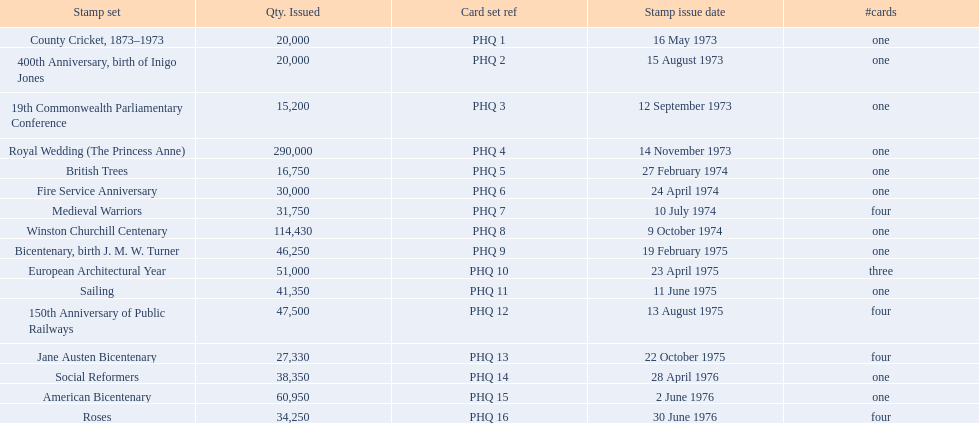What are all the stamp sets? County Cricket, 1873–1973, 400th Anniversary, birth of Inigo Jones, 19th Commonwealth Parliamentary Conference, Royal Wedding (The Princess Anne), British Trees, Fire Service Anniversary, Medieval Warriors, Winston Churchill Centenary, Bicentenary, birth J. M. W. Turner, European Architectural Year, Sailing, 150th Anniversary of Public Railways, Jane Austen Bicentenary, Social Reformers, American Bicentenary, Roses. For these sets, what were the quantities issued? 20,000, 20,000, 15,200, 290,000, 16,750, 30,000, 31,750, 114,430, 46,250, 51,000, 41,350, 47,500, 27,330, 38,350, 60,950, 34,250. Of these, which quantity is above 200,000? 290,000. What is the stamp set corresponding to this quantity? Royal Wedding (The Princess Anne). 